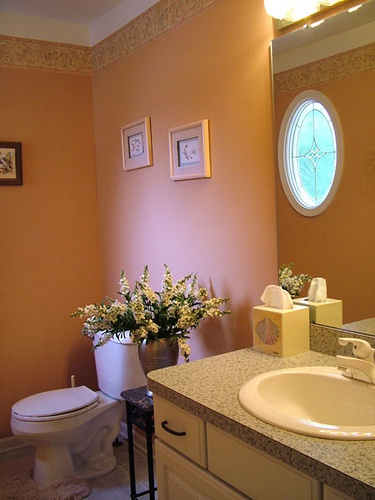Describe the objects in this image and their specific colors. I can see toilet in gray, maroon, brown, and darkgray tones, sink in gray and tan tones, potted plant in gray, black, olive, maroon, and tan tones, vase in gray, maroon, black, and brown tones, and potted plant in gray, tan, and olive tones in this image. 